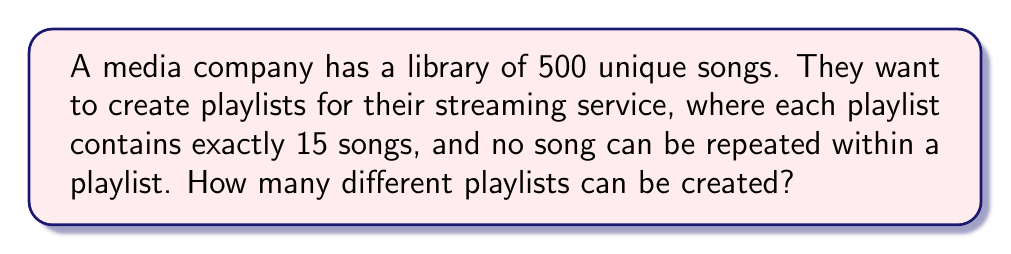Give your solution to this math problem. To solve this problem, we need to use the concept of permutations. Here's a step-by-step explanation:

1. We are selecting 15 songs from a total of 500 songs.
2. The order of the songs in the playlist matters (e.g., Song A followed by Song B is different from Song B followed by Song A).
3. We cannot repeat any song in a single playlist.

This scenario fits the formula for permutations without repetition:

$$P(n,r) = \frac{n!}{(n-r)!}$$

Where:
$n$ = total number of items to choose from (500 songs)
$r$ = number of items being chosen (15 songs in each playlist)

Plugging in our values:

$$P(500,15) = \frac{500!}{(500-15)!} = \frac{500!}{485!}$$

To calculate this:

1. Expand the numerator:
   $$500 \times 499 \times 498 \times ... \times 487 \times 486$$

2. This is equivalent to:
   $$\frac{500!}{485!} = 500 \times 499 \times 498 \times ... \times 487 \times 486$$

3. Multiply these 15 numbers together to get the final result.
Answer: $1.9766 \times 10^{41}$ different playlists 